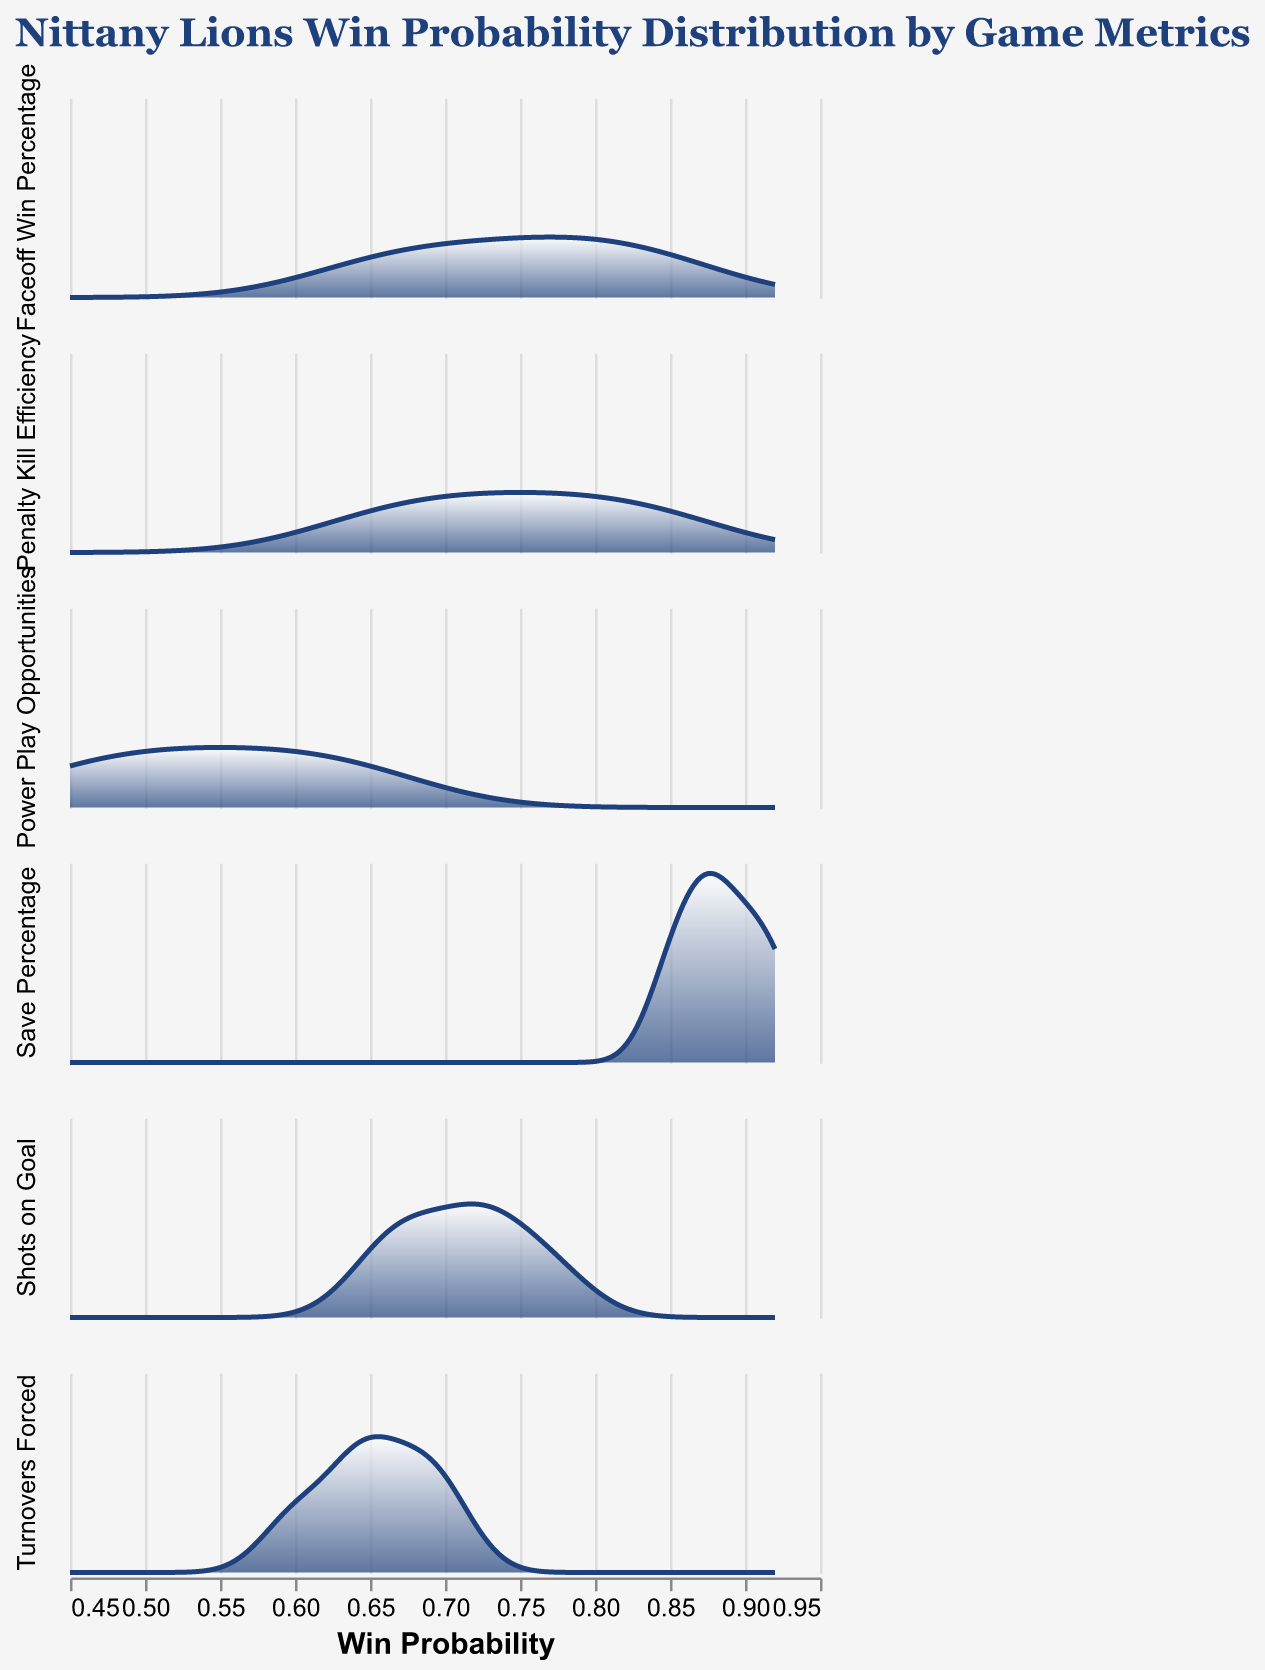What is the title of the figure? The title is typically at the top of the figure in a larger font size and often in a distinct color. In this case, the title says "Nittany Lions Win Probability Distribution by Game Metrics".
Answer: Nittany Lions Win Probability Distribution by Game Metrics What in-game metric appears in the subplot with the highest win probability density? To determine this, you need to look at the area under each density curve within the subplots. The "Save Percentage" subplot has the highest win probability density, reaching superior win probabilities more often.
Answer: Save Percentage Which in-game metric has the broadest range of win probabilities? By observing the spread of the densities along the x-axis, "Faceoff Win Percentage" spans from about 0.65 to 0.85, indicating a broad range.
Answer: Faceoff Win Percentage On which in-game metric do the Nittany Lions have the lowest win probability? This can be found by looking where the density reaches the lowest part of the x-axis. "Power Play Opportunities" includes a win probability as low as 0.45.
Answer: Power Play Opportunities How does the win probability distribution of "Shots on Goal" compare to that of "Turnovers Forced"? By comparing the density curves, "Shots on Goal" generally shows higher win probabilities than "Turnovers Forced", which has a more spread-out density.
Answer: Shots on Goal generally has higher win probabilities Which in-game metric shows the highest peak in its win probability distribution? The peak of the density within a subplot shows the most common win probability. In the figure, "Save Percentage" reaches the highest peak.
Answer: Save Percentage What's the average win probability for "Penalty Kill Efficiency"? Average is calculated by summing the probabilities and dividing by the number of points. Summing (0.70+0.75+0.85+0.65+0.80)/5 = 3.75/5.
Answer: 0.75 Between "Save Percentage" and "Faceoff Win Percentage", which metric shows less variance in win probabilities? Variance can be inferred by the spread of the density curve; a tighter curve means less variance. "Save Percentage" has a tighter curve compared to "Faceoff Win Percentage".
Answer: Save Percentage Which metrics have overlapping win probability ranges? To find overlaps, observe where different metrics' density curves cover the same x-axis ranges. "Faceoff Win Percentage" and "Penalty Kill Efficiency" both range around 0.65 to 0.85.
Answer: Faceoff Win Percentage and Penalty Kill Efficiency How does the density curve for "Turnovers Forced" shape compared to "Penalty Kill Efficiency"? By visual inspection, "Turnovers Forced" has a flatter and more spread-out curve, whereas "Penalty Kill Efficiency" has sharper peaks.
Answer: Turnovers Forced is flatter and more spread-out 